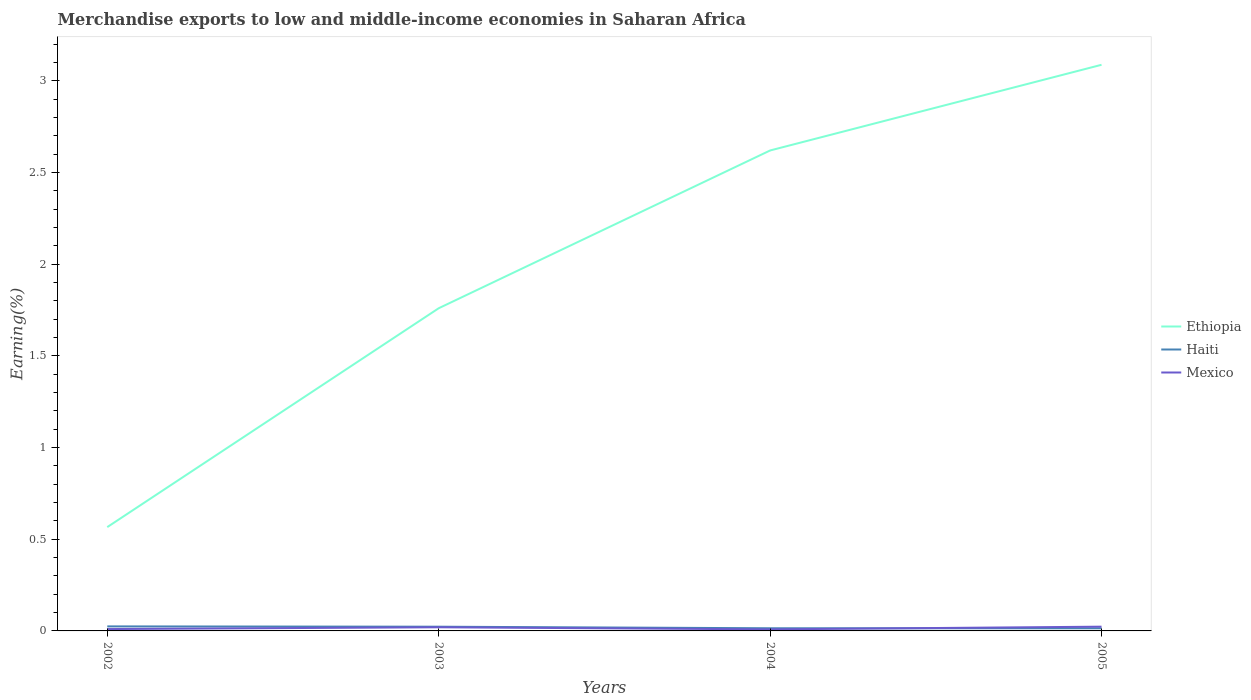How many different coloured lines are there?
Your answer should be very brief. 3. Does the line corresponding to Mexico intersect with the line corresponding to Ethiopia?
Your response must be concise. No. Across all years, what is the maximum percentage of amount earned from merchandise exports in Mexico?
Offer a very short reply. 0.01. What is the total percentage of amount earned from merchandise exports in Ethiopia in the graph?
Ensure brevity in your answer.  -2.52. What is the difference between the highest and the second highest percentage of amount earned from merchandise exports in Ethiopia?
Your answer should be compact. 2.52. What is the difference between the highest and the lowest percentage of amount earned from merchandise exports in Ethiopia?
Your answer should be very brief. 2. Is the percentage of amount earned from merchandise exports in Haiti strictly greater than the percentage of amount earned from merchandise exports in Mexico over the years?
Offer a very short reply. No. How many lines are there?
Make the answer very short. 3. How many years are there in the graph?
Your response must be concise. 4. Does the graph contain any zero values?
Provide a succinct answer. No. Does the graph contain grids?
Give a very brief answer. No. How are the legend labels stacked?
Provide a short and direct response. Vertical. What is the title of the graph?
Ensure brevity in your answer.  Merchandise exports to low and middle-income economies in Saharan Africa. What is the label or title of the X-axis?
Offer a terse response. Years. What is the label or title of the Y-axis?
Offer a very short reply. Earning(%). What is the Earning(%) of Ethiopia in 2002?
Ensure brevity in your answer.  0.57. What is the Earning(%) in Haiti in 2002?
Give a very brief answer. 0.02. What is the Earning(%) in Mexico in 2002?
Your answer should be very brief. 0.01. What is the Earning(%) in Ethiopia in 2003?
Offer a terse response. 1.76. What is the Earning(%) in Haiti in 2003?
Give a very brief answer. 0.02. What is the Earning(%) in Mexico in 2003?
Your answer should be very brief. 0.02. What is the Earning(%) of Ethiopia in 2004?
Give a very brief answer. 2.62. What is the Earning(%) of Haiti in 2004?
Offer a terse response. 0.01. What is the Earning(%) in Mexico in 2004?
Provide a short and direct response. 0.01. What is the Earning(%) in Ethiopia in 2005?
Ensure brevity in your answer.  3.09. What is the Earning(%) in Haiti in 2005?
Your response must be concise. 0.01. What is the Earning(%) in Mexico in 2005?
Provide a short and direct response. 0.02. Across all years, what is the maximum Earning(%) in Ethiopia?
Make the answer very short. 3.09. Across all years, what is the maximum Earning(%) of Haiti?
Your response must be concise. 0.02. Across all years, what is the maximum Earning(%) in Mexico?
Provide a short and direct response. 0.02. Across all years, what is the minimum Earning(%) of Ethiopia?
Provide a short and direct response. 0.57. Across all years, what is the minimum Earning(%) of Haiti?
Make the answer very short. 0.01. Across all years, what is the minimum Earning(%) of Mexico?
Make the answer very short. 0.01. What is the total Earning(%) in Ethiopia in the graph?
Give a very brief answer. 8.04. What is the total Earning(%) in Haiti in the graph?
Offer a terse response. 0.08. What is the total Earning(%) in Mexico in the graph?
Provide a short and direct response. 0.06. What is the difference between the Earning(%) in Ethiopia in 2002 and that in 2003?
Provide a short and direct response. -1.19. What is the difference between the Earning(%) of Haiti in 2002 and that in 2003?
Offer a terse response. 0. What is the difference between the Earning(%) in Mexico in 2002 and that in 2003?
Provide a short and direct response. -0.01. What is the difference between the Earning(%) in Ethiopia in 2002 and that in 2004?
Provide a succinct answer. -2.05. What is the difference between the Earning(%) in Haiti in 2002 and that in 2004?
Make the answer very short. 0.01. What is the difference between the Earning(%) in Mexico in 2002 and that in 2004?
Your answer should be very brief. 0. What is the difference between the Earning(%) of Ethiopia in 2002 and that in 2005?
Your response must be concise. -2.52. What is the difference between the Earning(%) of Haiti in 2002 and that in 2005?
Provide a short and direct response. 0.01. What is the difference between the Earning(%) in Mexico in 2002 and that in 2005?
Provide a short and direct response. -0.01. What is the difference between the Earning(%) in Ethiopia in 2003 and that in 2004?
Make the answer very short. -0.86. What is the difference between the Earning(%) in Haiti in 2003 and that in 2004?
Offer a very short reply. 0.01. What is the difference between the Earning(%) in Mexico in 2003 and that in 2004?
Offer a terse response. 0.01. What is the difference between the Earning(%) in Ethiopia in 2003 and that in 2005?
Provide a short and direct response. -1.33. What is the difference between the Earning(%) in Haiti in 2003 and that in 2005?
Your answer should be very brief. 0.01. What is the difference between the Earning(%) of Mexico in 2003 and that in 2005?
Offer a very short reply. -0. What is the difference between the Earning(%) in Ethiopia in 2004 and that in 2005?
Keep it short and to the point. -0.47. What is the difference between the Earning(%) of Mexico in 2004 and that in 2005?
Offer a terse response. -0.01. What is the difference between the Earning(%) in Ethiopia in 2002 and the Earning(%) in Haiti in 2003?
Offer a terse response. 0.54. What is the difference between the Earning(%) of Ethiopia in 2002 and the Earning(%) of Mexico in 2003?
Ensure brevity in your answer.  0.55. What is the difference between the Earning(%) in Haiti in 2002 and the Earning(%) in Mexico in 2003?
Give a very brief answer. 0. What is the difference between the Earning(%) in Ethiopia in 2002 and the Earning(%) in Haiti in 2004?
Keep it short and to the point. 0.55. What is the difference between the Earning(%) in Ethiopia in 2002 and the Earning(%) in Mexico in 2004?
Your answer should be compact. 0.56. What is the difference between the Earning(%) of Haiti in 2002 and the Earning(%) of Mexico in 2004?
Offer a terse response. 0.02. What is the difference between the Earning(%) in Ethiopia in 2002 and the Earning(%) in Haiti in 2005?
Provide a short and direct response. 0.55. What is the difference between the Earning(%) of Ethiopia in 2002 and the Earning(%) of Mexico in 2005?
Make the answer very short. 0.54. What is the difference between the Earning(%) of Haiti in 2002 and the Earning(%) of Mexico in 2005?
Your answer should be compact. 0. What is the difference between the Earning(%) of Ethiopia in 2003 and the Earning(%) of Haiti in 2004?
Offer a very short reply. 1.75. What is the difference between the Earning(%) of Ethiopia in 2003 and the Earning(%) of Mexico in 2004?
Ensure brevity in your answer.  1.75. What is the difference between the Earning(%) of Haiti in 2003 and the Earning(%) of Mexico in 2004?
Ensure brevity in your answer.  0.01. What is the difference between the Earning(%) of Ethiopia in 2003 and the Earning(%) of Haiti in 2005?
Offer a very short reply. 1.75. What is the difference between the Earning(%) of Ethiopia in 2003 and the Earning(%) of Mexico in 2005?
Offer a very short reply. 1.74. What is the difference between the Earning(%) in Haiti in 2003 and the Earning(%) in Mexico in 2005?
Offer a very short reply. -0. What is the difference between the Earning(%) of Ethiopia in 2004 and the Earning(%) of Haiti in 2005?
Your answer should be compact. 2.61. What is the difference between the Earning(%) in Ethiopia in 2004 and the Earning(%) in Mexico in 2005?
Make the answer very short. 2.6. What is the difference between the Earning(%) of Haiti in 2004 and the Earning(%) of Mexico in 2005?
Give a very brief answer. -0.01. What is the average Earning(%) in Ethiopia per year?
Provide a succinct answer. 2.01. What is the average Earning(%) of Haiti per year?
Keep it short and to the point. 0.02. What is the average Earning(%) in Mexico per year?
Make the answer very short. 0.02. In the year 2002, what is the difference between the Earning(%) in Ethiopia and Earning(%) in Haiti?
Offer a very short reply. 0.54. In the year 2002, what is the difference between the Earning(%) in Ethiopia and Earning(%) in Mexico?
Provide a short and direct response. 0.56. In the year 2002, what is the difference between the Earning(%) in Haiti and Earning(%) in Mexico?
Offer a very short reply. 0.01. In the year 2003, what is the difference between the Earning(%) of Ethiopia and Earning(%) of Haiti?
Provide a succinct answer. 1.74. In the year 2003, what is the difference between the Earning(%) of Ethiopia and Earning(%) of Mexico?
Make the answer very short. 1.74. In the year 2003, what is the difference between the Earning(%) of Haiti and Earning(%) of Mexico?
Provide a short and direct response. 0. In the year 2004, what is the difference between the Earning(%) in Ethiopia and Earning(%) in Haiti?
Your response must be concise. 2.61. In the year 2004, what is the difference between the Earning(%) of Ethiopia and Earning(%) of Mexico?
Make the answer very short. 2.61. In the year 2004, what is the difference between the Earning(%) in Haiti and Earning(%) in Mexico?
Your response must be concise. 0.01. In the year 2005, what is the difference between the Earning(%) of Ethiopia and Earning(%) of Haiti?
Offer a very short reply. 3.07. In the year 2005, what is the difference between the Earning(%) in Ethiopia and Earning(%) in Mexico?
Keep it short and to the point. 3.07. In the year 2005, what is the difference between the Earning(%) in Haiti and Earning(%) in Mexico?
Provide a short and direct response. -0.01. What is the ratio of the Earning(%) in Ethiopia in 2002 to that in 2003?
Provide a short and direct response. 0.32. What is the ratio of the Earning(%) of Haiti in 2002 to that in 2003?
Keep it short and to the point. 1.07. What is the ratio of the Earning(%) of Mexico in 2002 to that in 2003?
Your response must be concise. 0.51. What is the ratio of the Earning(%) of Ethiopia in 2002 to that in 2004?
Give a very brief answer. 0.22. What is the ratio of the Earning(%) of Haiti in 2002 to that in 2004?
Offer a very short reply. 1.7. What is the ratio of the Earning(%) of Mexico in 2002 to that in 2004?
Give a very brief answer. 1.2. What is the ratio of the Earning(%) of Ethiopia in 2002 to that in 2005?
Provide a short and direct response. 0.18. What is the ratio of the Earning(%) in Haiti in 2002 to that in 2005?
Offer a very short reply. 1.73. What is the ratio of the Earning(%) of Mexico in 2002 to that in 2005?
Your answer should be very brief. 0.44. What is the ratio of the Earning(%) in Ethiopia in 2003 to that in 2004?
Keep it short and to the point. 0.67. What is the ratio of the Earning(%) in Haiti in 2003 to that in 2004?
Make the answer very short. 1.59. What is the ratio of the Earning(%) in Mexico in 2003 to that in 2004?
Keep it short and to the point. 2.35. What is the ratio of the Earning(%) of Ethiopia in 2003 to that in 2005?
Your answer should be very brief. 0.57. What is the ratio of the Earning(%) in Haiti in 2003 to that in 2005?
Offer a very short reply. 1.61. What is the ratio of the Earning(%) of Mexico in 2003 to that in 2005?
Your answer should be compact. 0.86. What is the ratio of the Earning(%) in Ethiopia in 2004 to that in 2005?
Your response must be concise. 0.85. What is the ratio of the Earning(%) of Haiti in 2004 to that in 2005?
Offer a terse response. 1.02. What is the ratio of the Earning(%) in Mexico in 2004 to that in 2005?
Provide a short and direct response. 0.37. What is the difference between the highest and the second highest Earning(%) in Ethiopia?
Give a very brief answer. 0.47. What is the difference between the highest and the second highest Earning(%) of Haiti?
Keep it short and to the point. 0. What is the difference between the highest and the second highest Earning(%) of Mexico?
Your answer should be very brief. 0. What is the difference between the highest and the lowest Earning(%) in Ethiopia?
Offer a very short reply. 2.52. What is the difference between the highest and the lowest Earning(%) in Haiti?
Your answer should be compact. 0.01. What is the difference between the highest and the lowest Earning(%) in Mexico?
Your answer should be very brief. 0.01. 